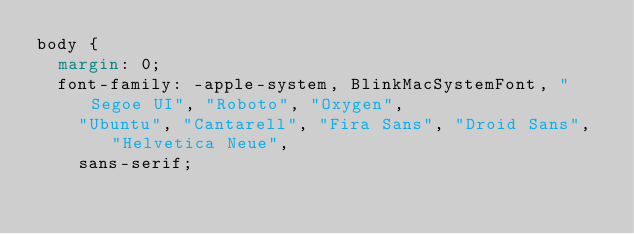<code> <loc_0><loc_0><loc_500><loc_500><_CSS_>body {
  margin: 0;
  font-family: -apple-system, BlinkMacSystemFont, "Segoe UI", "Roboto", "Oxygen",
    "Ubuntu", "Cantarell", "Fira Sans", "Droid Sans", "Helvetica Neue",
    sans-serif;</code> 